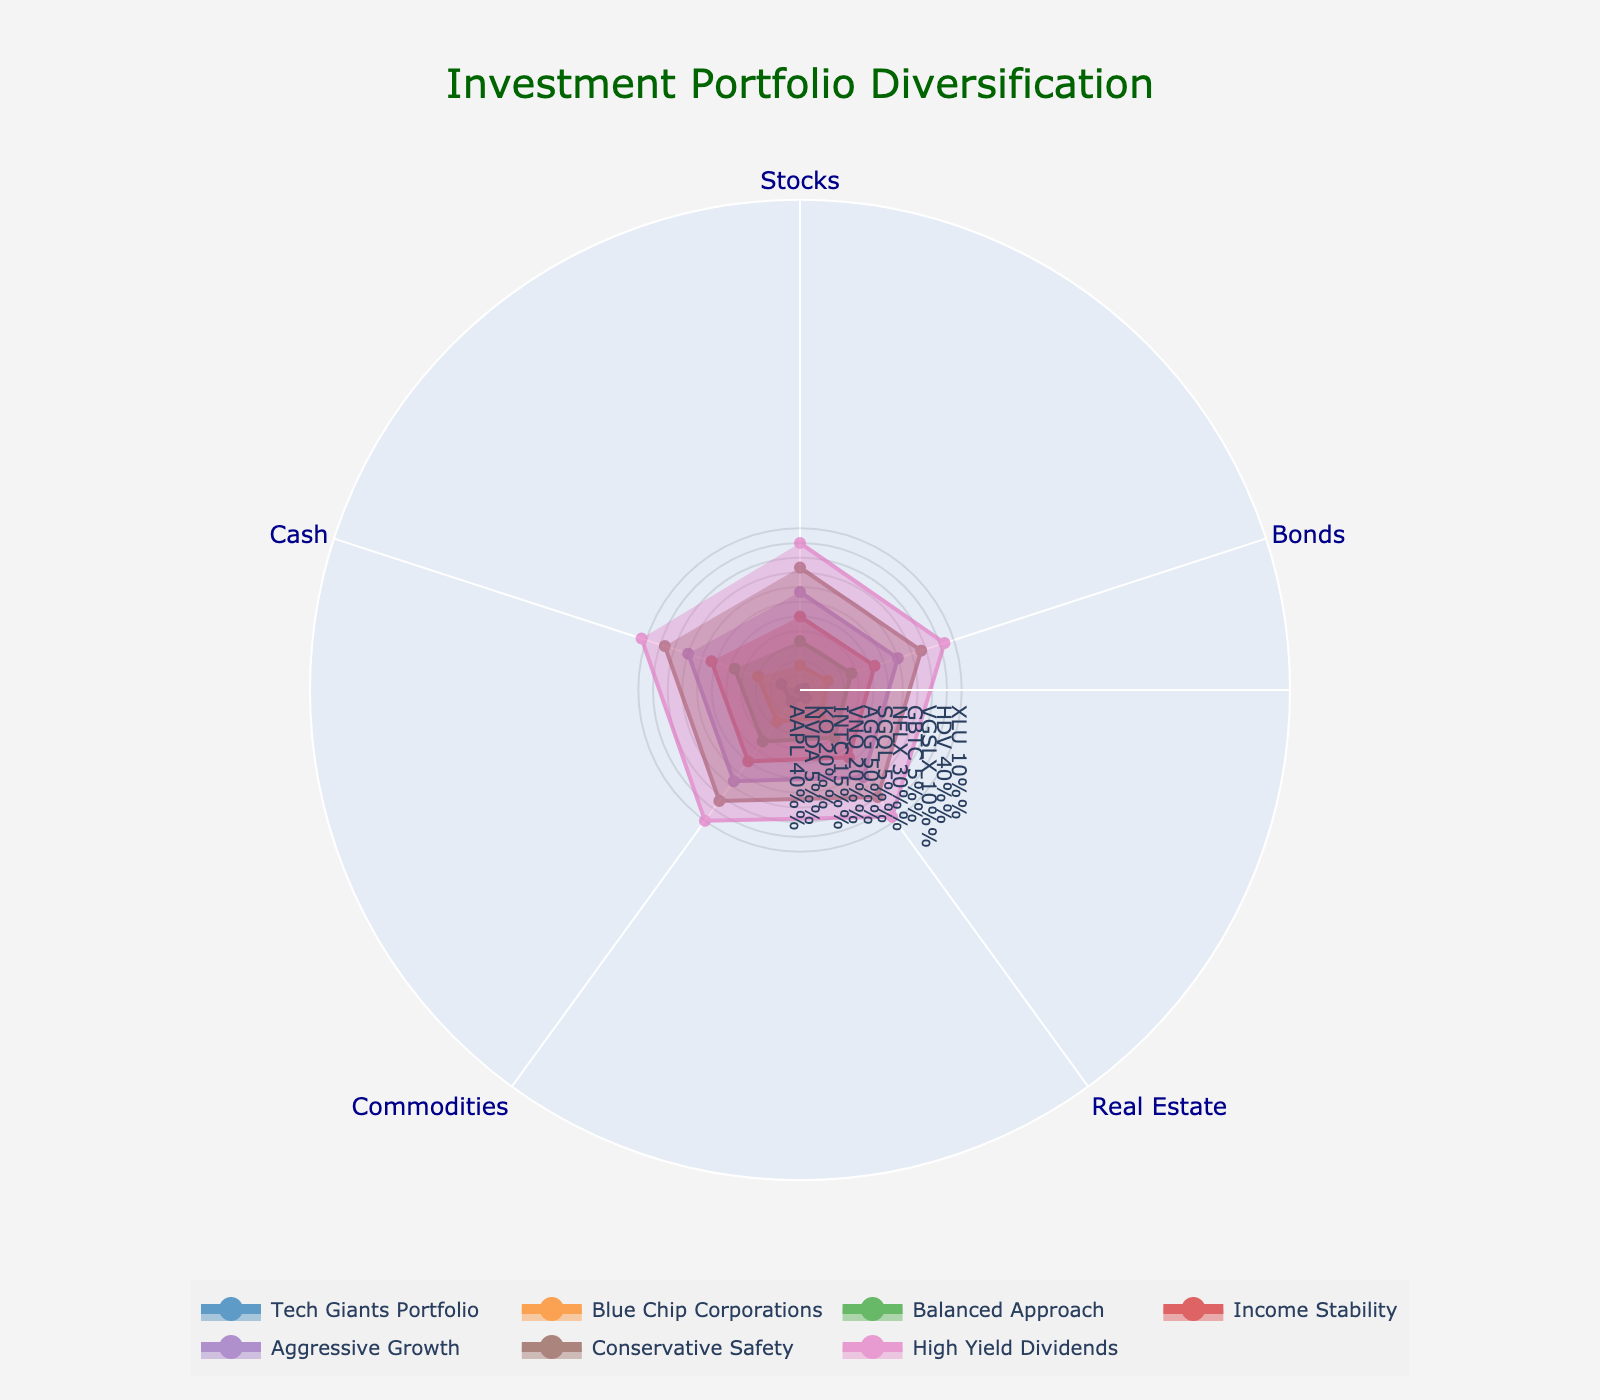How many investment portfolios are there in the radar chart? Count the names of different asset categories on the chart; each category represents a portfolio.
Answer: 7 What is the title of the radar chart? Look at the title typically displayed at the top of the figure.
Answer: Investment Portfolio Diversification Which portfolio has the highest allocation to bonds? Identify the portfolio with the highest percentage under the "Bonds" category. The "Income Stability" portfolio allocates 50% to bonds.
Answer: Income Stability Which portfolios have an equal allocation percentage for cash? Check the "Cash" allocations across all portfolios and note which ones share the same percentage. "Balanced Approach" and "Conservative Safety" both allocate 10% to cash.
Answer: Balanced Approach, Conservative Safety What is the average allocation to stocks across all portfolios? Sum up the stock allocations for each portfolio, then divide by the number of portfolios: (40%+25%+30%+50%+20%+10%)/7 = 29%
Answer: 29% Compare the Tech Giants Portfolio and Aggressive Growth. Which one allocates a higher percentage to stocks? Examine the "Stocks" category for each portfolio. "Tech Giants" allocates 40%, while "Aggressive Growth" allocates 50%.
Answer: Aggressive Growth Which portfolio has the most diversified allocation (the most categories with significant allocation)? Look for the portfolio that has the smallest differences among its category allocations. "Balanced Approach" has more evenly distributed percentages among all categories.
Answer: Balanced Approach What is the total percentage allocation to real estate for the High Yield Dividends and Income Stability portfolios combined? Add the real estate percentages for both portfolios: 10% + 10% = 20%.
Answer: 20% Which portfolio has the least amount of cash allocation? Identify the portfolio with the smallest percentage under the "Cash" category. "Aggressive Growth" has 0% allocation to cash.
Answer: Aggressive Growth Is there any portfolio with an equal percentage allocation across all categories? Check if any portfolio has uniform percentages in every asset category. None of the portfolios have equal percentage allocations across all five categories.
Answer: No 